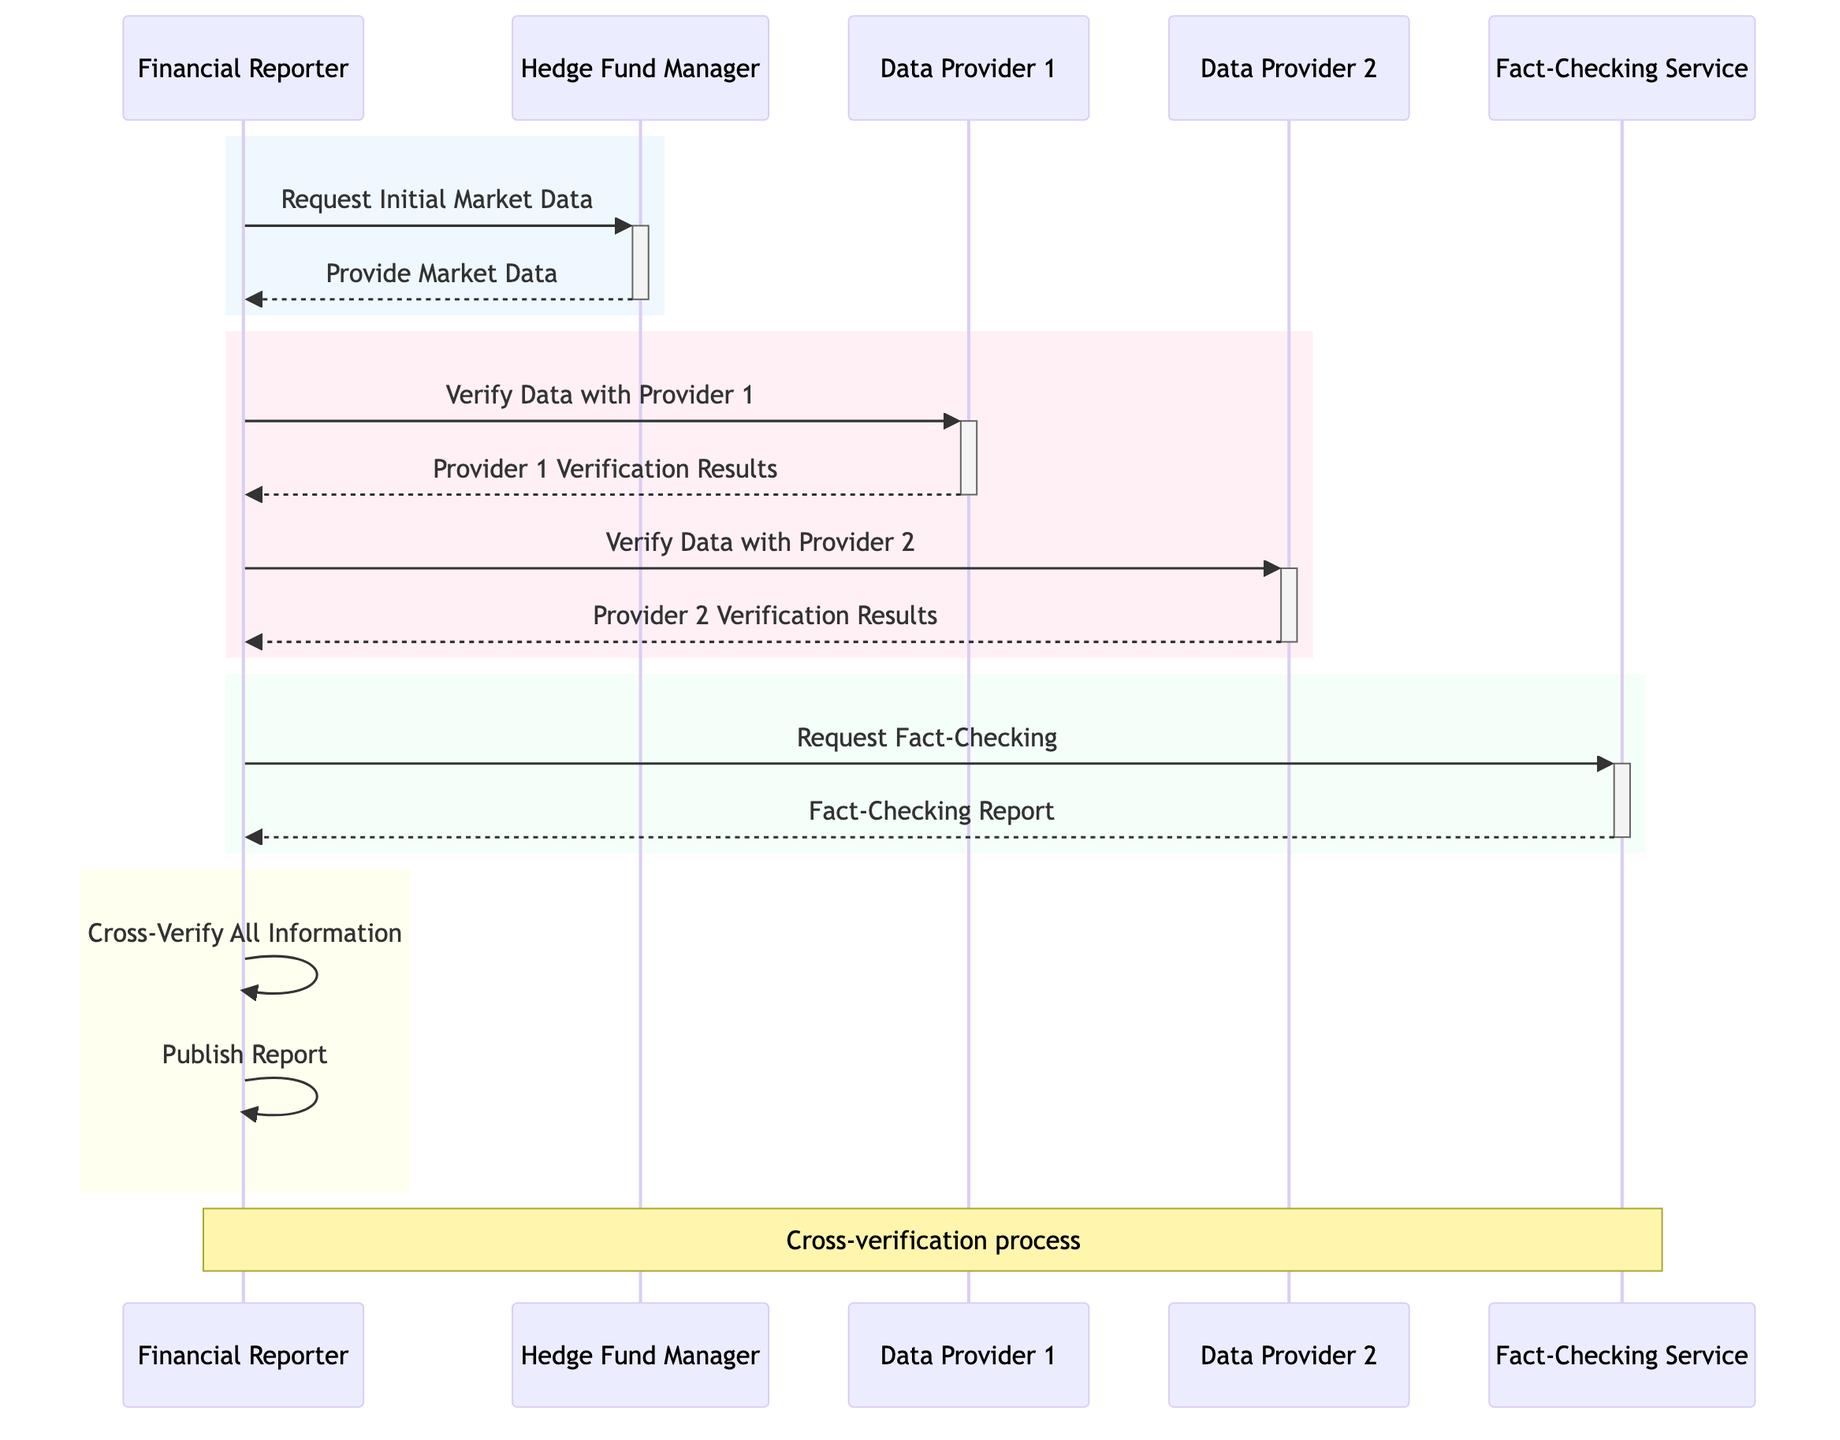What is the first action taken by the Financial Reporter? According to the diagram, the first action taken by the Financial Reporter is to request initial market data from the Hedge Fund Manager. This can be seen as the first line of interaction in the sequence.
Answer: Request Initial Market Data How many data providers are involved in the verification process? The diagram shows that there are two data providers: Data Provider 1 and Data Provider 2. This is indicated by the two separate interactions where the Financial Reporter requests verification from each provider.
Answer: Two What does the Financial Reporter request from the Fact-Checking Service? The diagram indicates that the Financial Reporter requests fact-checking from the Fact-Checking Service. This is represented by the interaction that connects the Financial Reporter to the Fact-Checking Service.
Answer: Request Fact-Checking What are the last two actions performed by the Financial Reporter? The last two actions performed by the Financial Reporter are to cross-verify all information and publish the report. These actions are depicted as self-interactions toward the end of the sequence.
Answer: Cross-Verify All Information, Publish Report In which step does the Financial Reporter interact with Data Provider 2? The Financial Reporter interacts with Data Provider 2 in the step labeled "Verify Data with Provider 2." This follows the interaction with Data Provider 1 and is clearly marked in the sequence.
Answer: Verify Data with Provider 2 What type of interaction occurs between the Financial Reporter and the Hedge Fund Manager? The interaction between the Financial Reporter and the Hedge Fund Manager is a request-response type, as the Financial Reporter requests initial market data and the Hedge Fund Manager responds by providing that data.
Answer: Request-Response Which actor provides verification results first? The first verification results are provided by Data Provider 1 after the Financial Reporter requests verification from them. This is the third interaction in the sequence.
Answer: Data Provider 1 What color is used to represent the section where data verification takes place? The section of the diagram representing data verification is colored in pink, which is indicated by the RGB color code given for that rectangle in the sequence diagram.
Answer: Pink What does the Financial Reporter do after receiving the Fact-Checking Report? After receiving the Fact-Checking Report, the Financial Reporter cross-verifies all information before ultimately publishing the report. These actions are represented as self-interactions in the diagram.
Answer: Cross-Verify All Information 